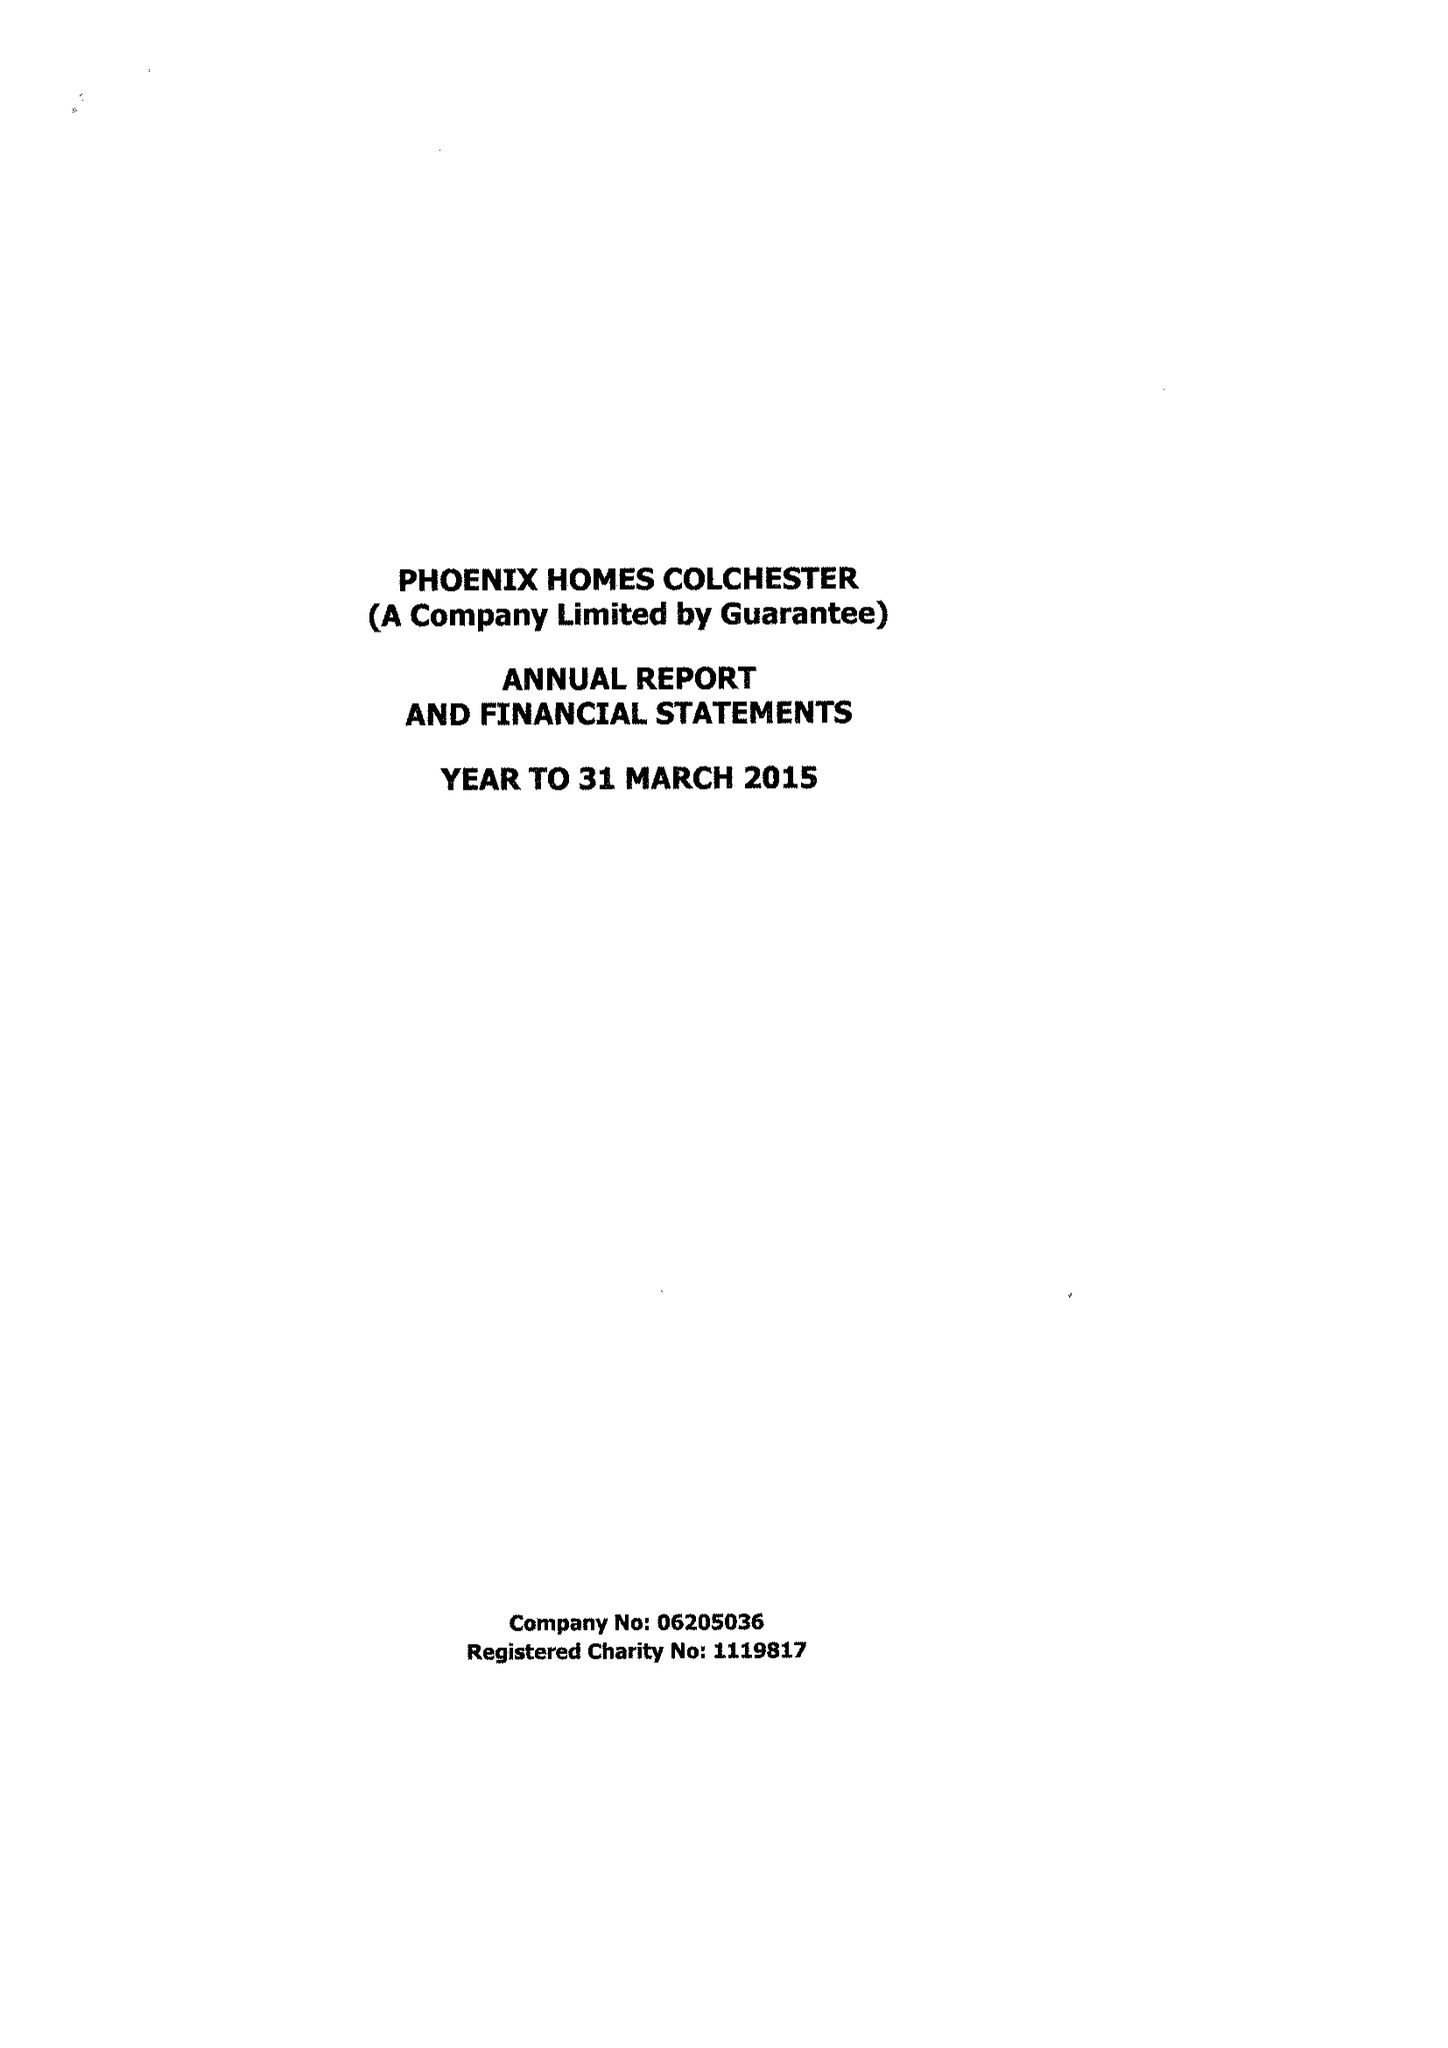What is the value for the charity_name?
Answer the question using a single word or phrase. Phoenix Homes Colchester 